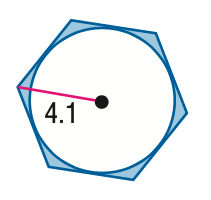Question: Find the area of the shaded region. Assume that all polygons that appear to be regular are regular. Round to the nearest tenth.
Choices:
A. 4.1
B. 9.1
C. 33.8
D. 36.0
Answer with the letter. Answer: A 